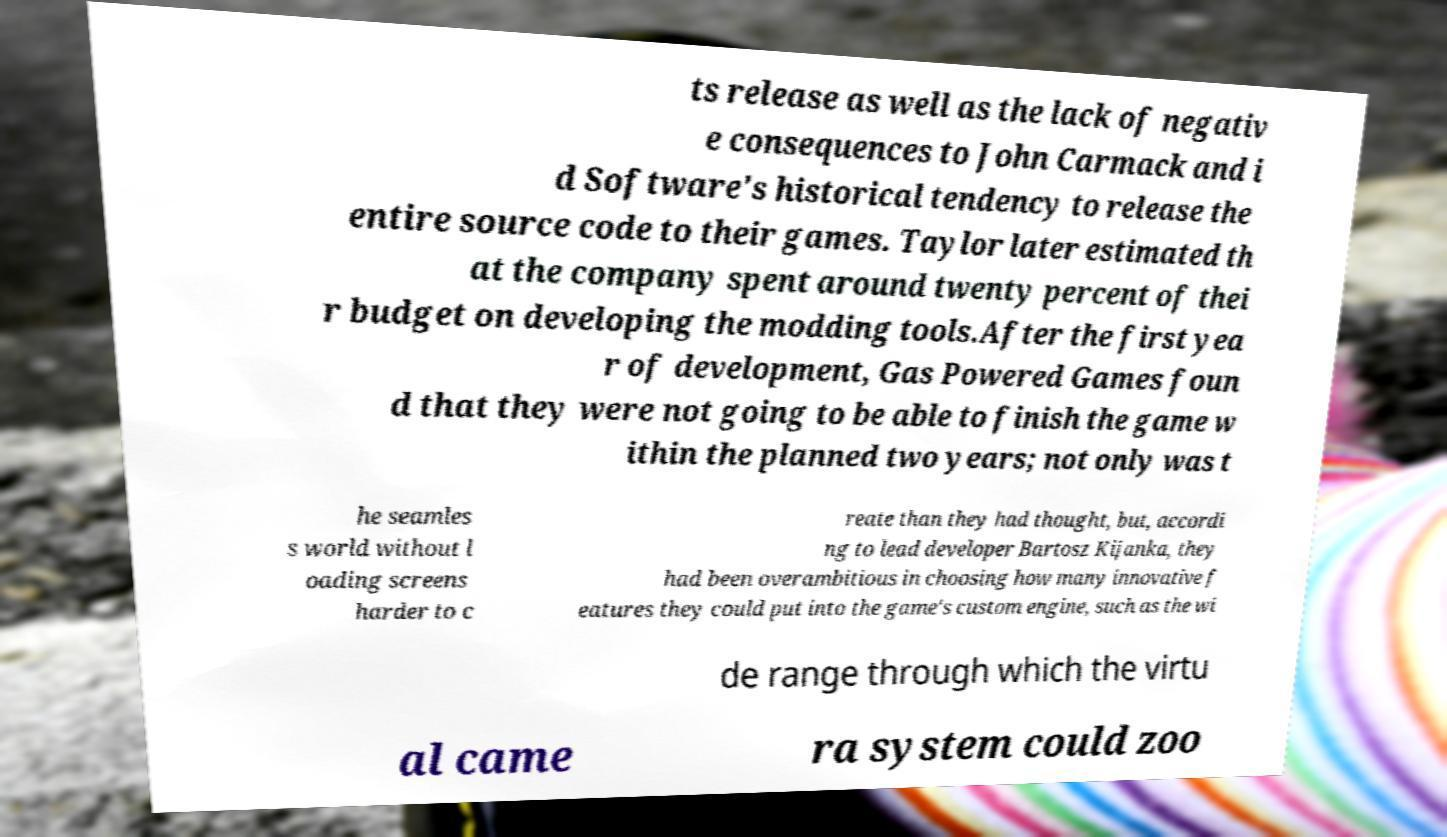Could you extract and type out the text from this image? ts release as well as the lack of negativ e consequences to John Carmack and i d Software's historical tendency to release the entire source code to their games. Taylor later estimated th at the company spent around twenty percent of thei r budget on developing the modding tools.After the first yea r of development, Gas Powered Games foun d that they were not going to be able to finish the game w ithin the planned two years; not only was t he seamles s world without l oading screens harder to c reate than they had thought, but, accordi ng to lead developer Bartosz Kijanka, they had been overambitious in choosing how many innovative f eatures they could put into the game's custom engine, such as the wi de range through which the virtu al came ra system could zoo 